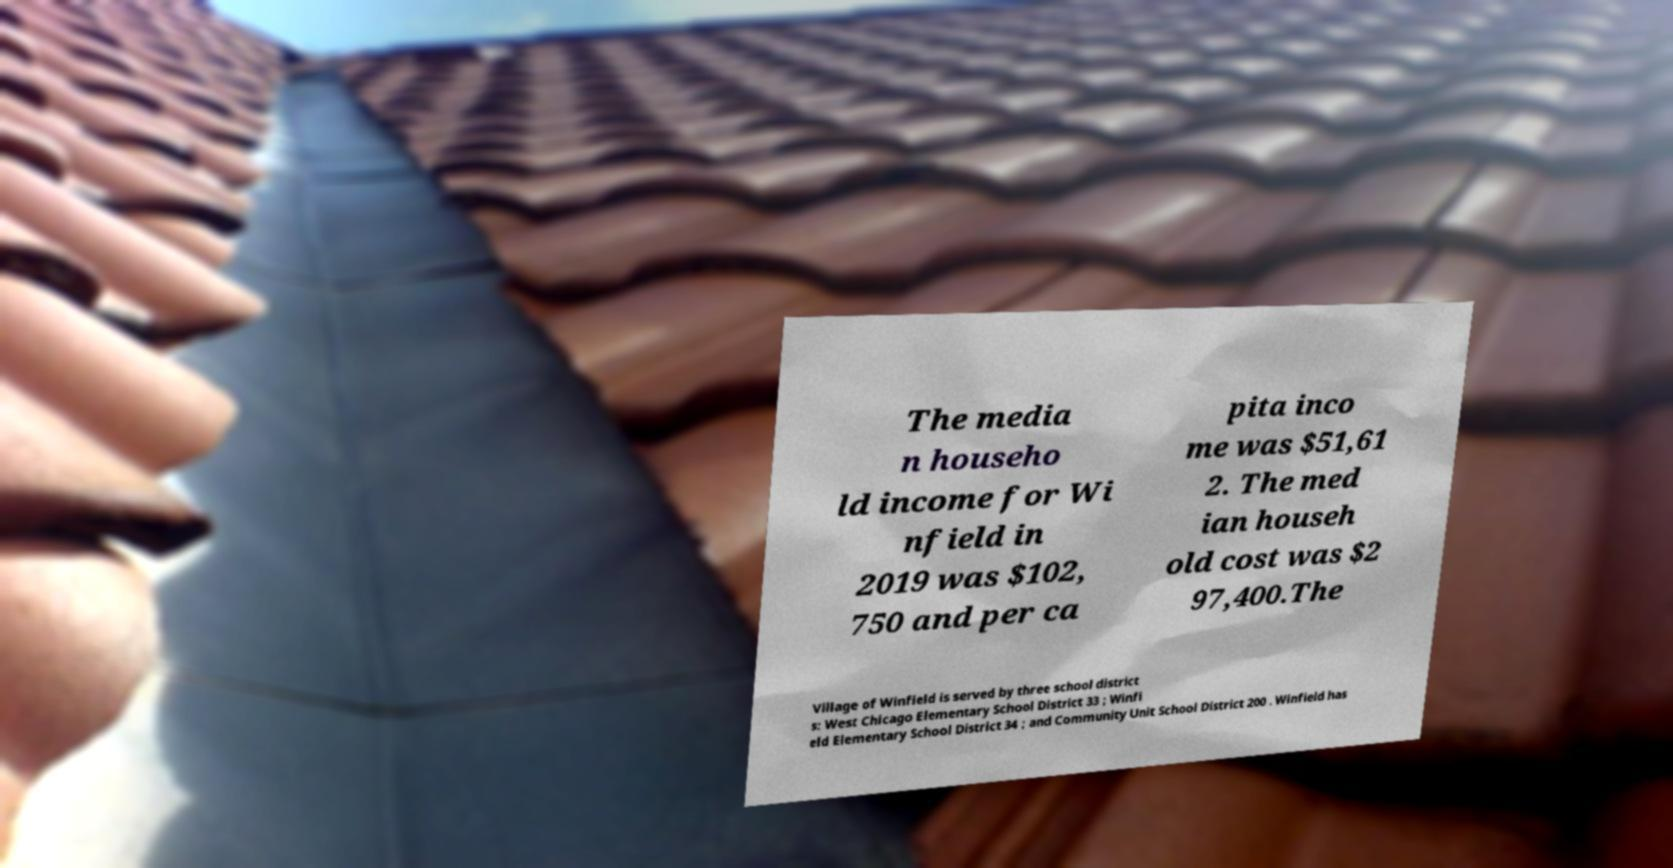Could you extract and type out the text from this image? The media n househo ld income for Wi nfield in 2019 was $102, 750 and per ca pita inco me was $51,61 2. The med ian househ old cost was $2 97,400.The Village of Winfield is served by three school district s: West Chicago Elementary School District 33 ; Winfi eld Elementary School District 34 ; and Community Unit School District 200 . Winfield has 